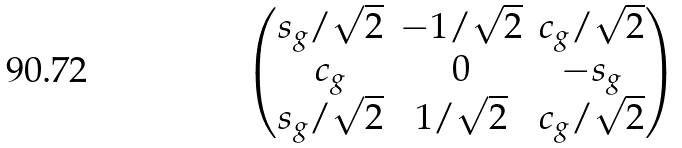<formula> <loc_0><loc_0><loc_500><loc_500>\begin{pmatrix} s _ { g } / \sqrt { 2 } & - 1 / \sqrt { 2 } & c _ { g } / \sqrt { 2 } \\ c _ { g } & 0 & - s _ { g } \\ s _ { g } / \sqrt { 2 } & 1 / \sqrt { 2 } & c _ { g } / \sqrt { 2 } \end{pmatrix}</formula> 